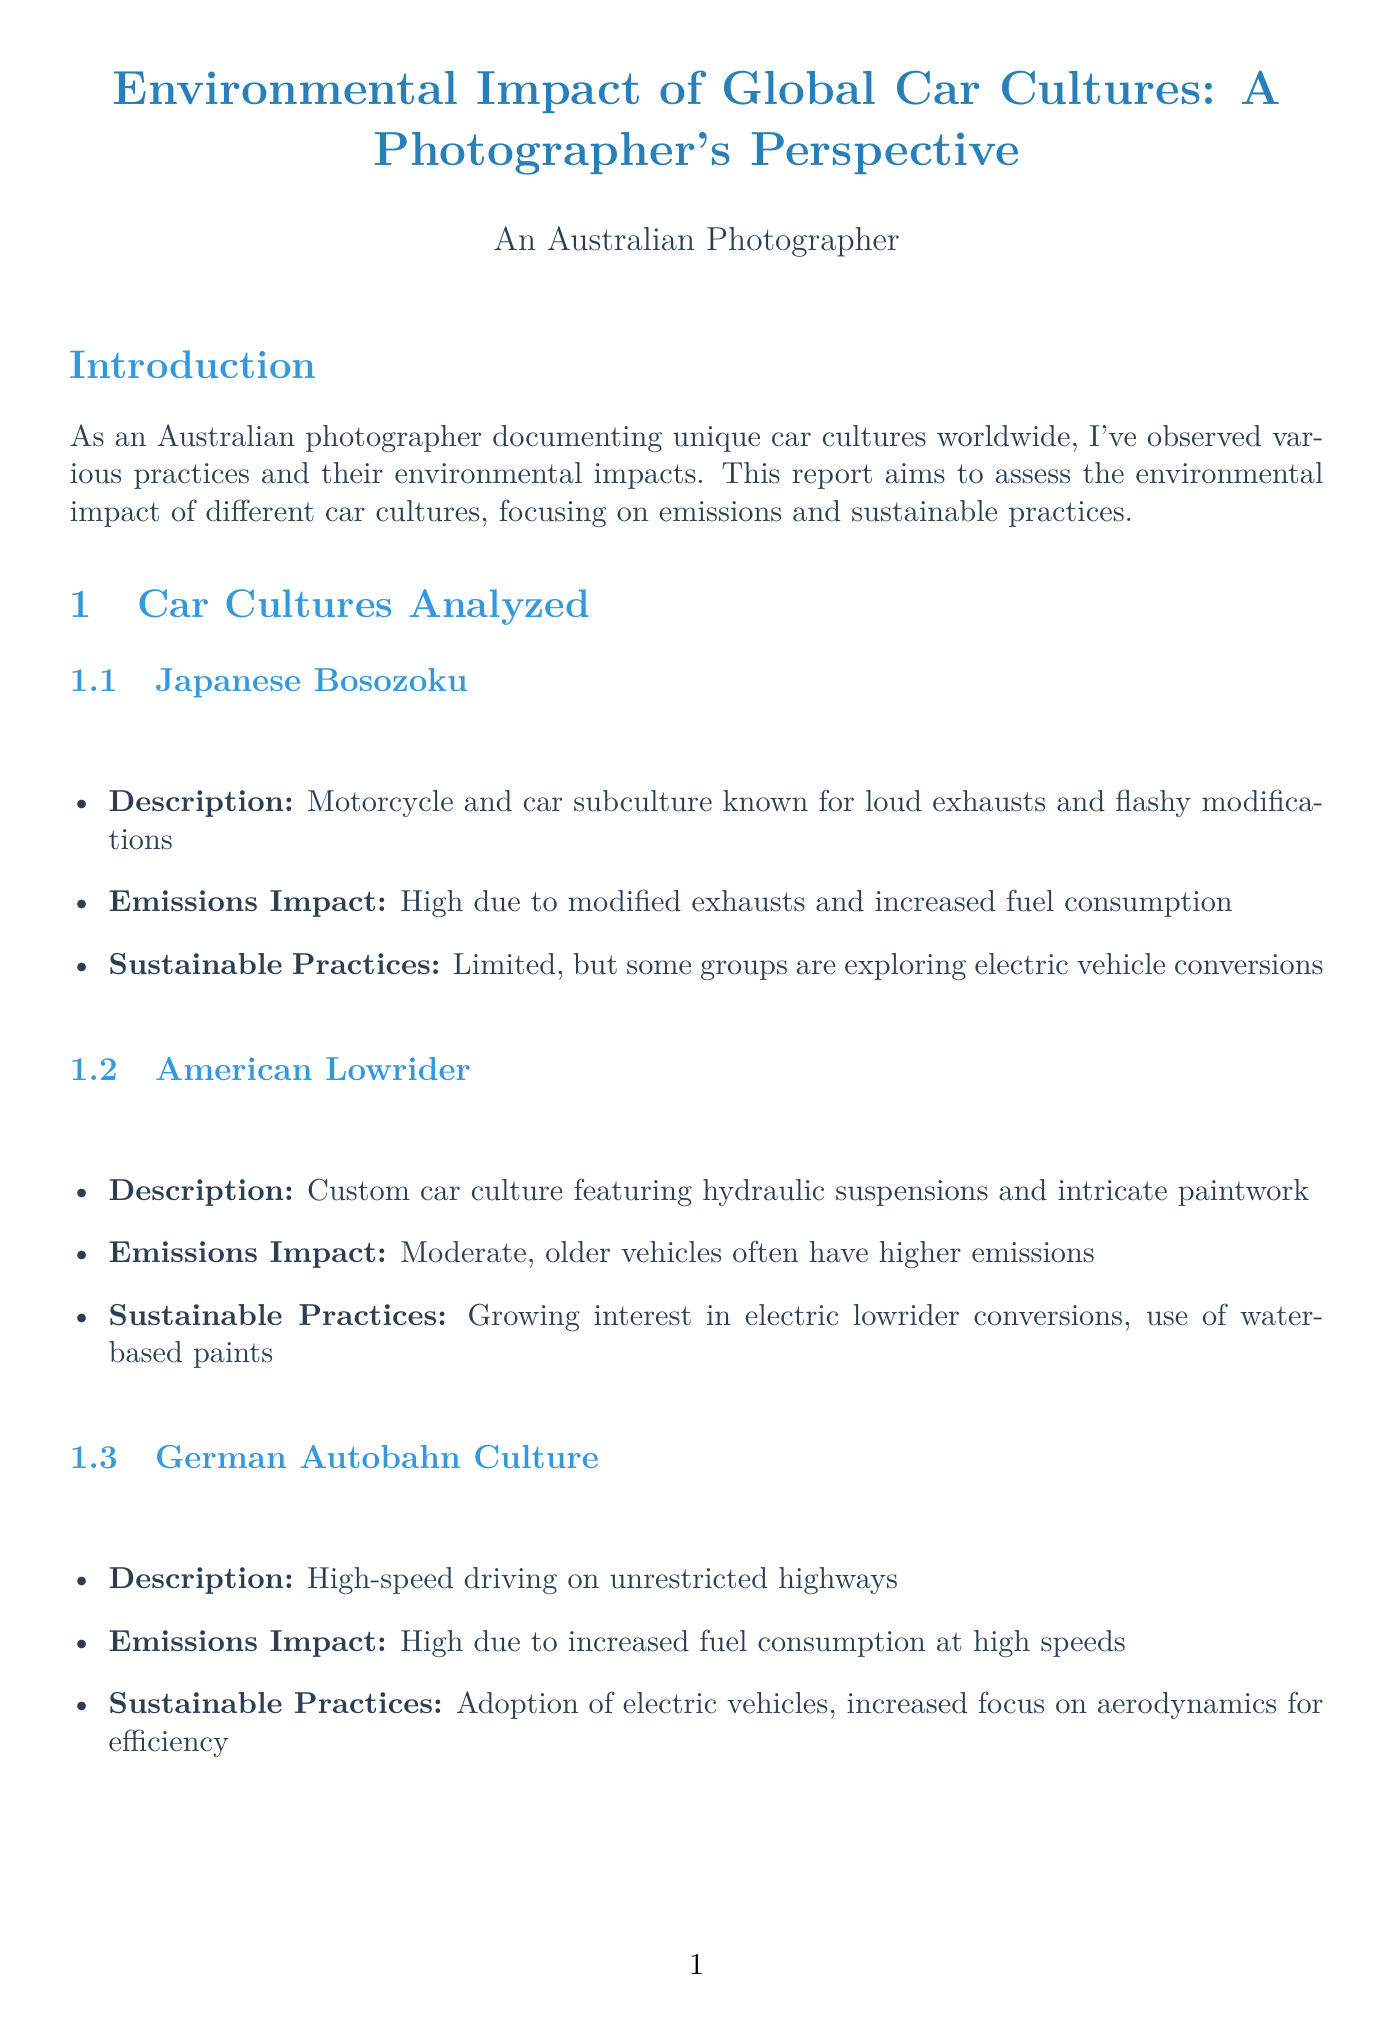what is the title of the report? The title of the report is stated at the beginning of the document.
Answer: Environmental Impact of Global Car Cultures: A Photographer's Perspective what is the emissions impact of American Lowrider culture? The emissions impact is described in the section about American Lowrider culture.
Answer: Moderate, older vehicles often have higher emissions what sustainable practice is being explored by Japanese Bosozoku groups? This practice is mentioned in the section on Japanese Bosozoku.
Answer: Electric vehicle conversions what environmental assessment method measures air quality? The method related to assessing air quality is listed under environmental assessment methods.
Answer: Air quality measurements at car events how many key points are outlined in the Summernats Sustainability Drive case study? The number of key points is specified in the case study section.
Answer: Three what is an example of a sustainable initiative in car shows? The example is given in the section on sustainable initiatives related to car shows.
Answer: The Fully Charged LIVE show in Australia which car culture is known for high-speed driving? The specific car culture is mentioned in the document.
Answer: German Autobahn Culture what recommendation is made regarding educational workshops? The specific recommendation can be found in the recommendations section.
Answer: Organize educational workshops on eco-friendly car maintenance 